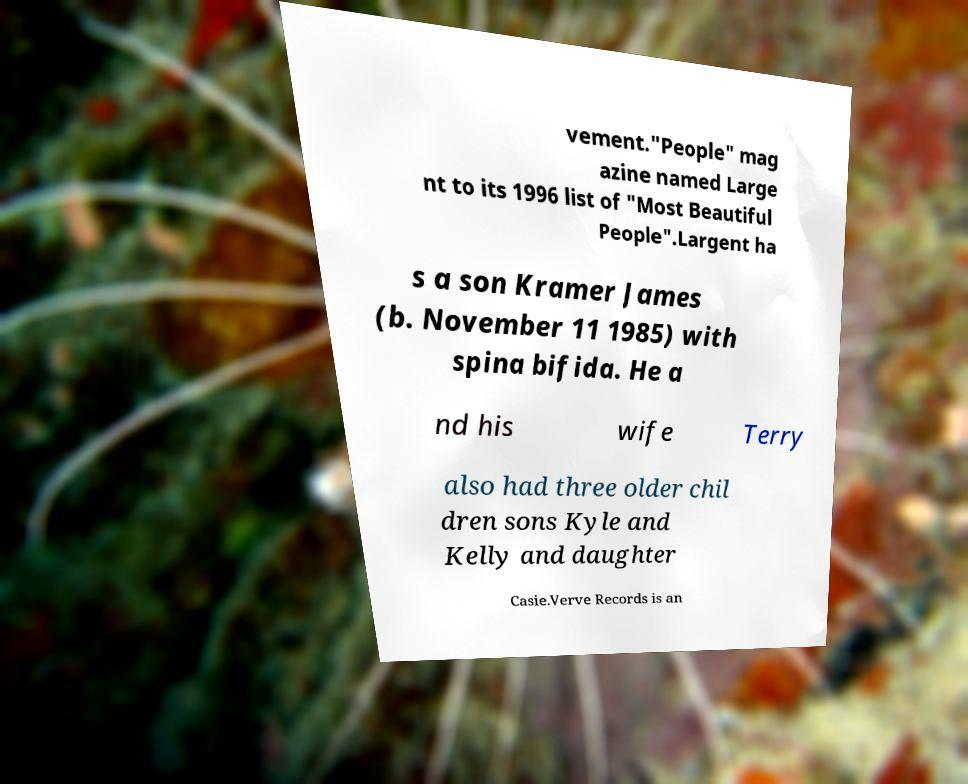There's text embedded in this image that I need extracted. Can you transcribe it verbatim? vement."People" mag azine named Large nt to its 1996 list of "Most Beautiful People".Largent ha s a son Kramer James (b. November 11 1985) with spina bifida. He a nd his wife Terry also had three older chil dren sons Kyle and Kelly and daughter Casie.Verve Records is an 